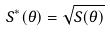Convert formula to latex. <formula><loc_0><loc_0><loc_500><loc_500>S ^ { * } ( \theta ) = \sqrt { S ( \theta ) }</formula> 